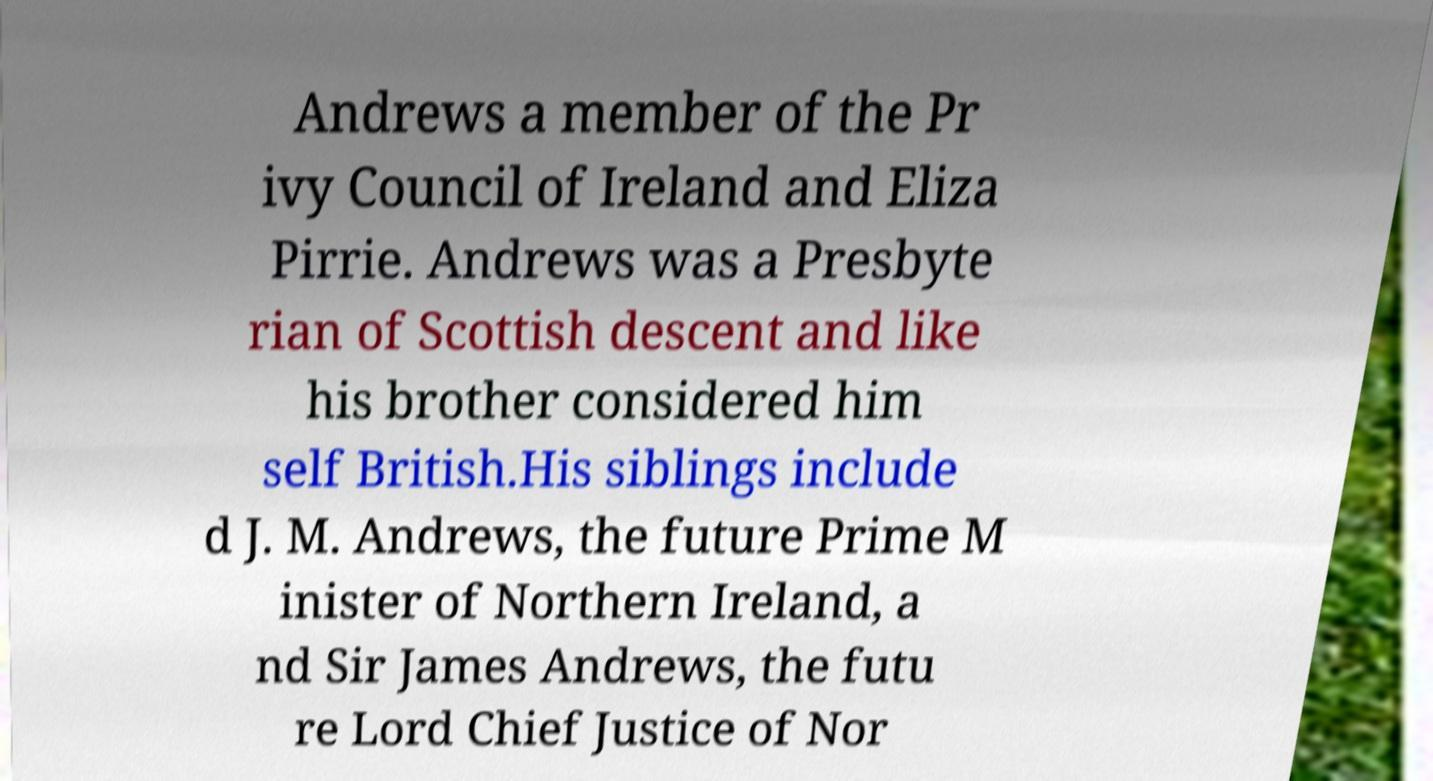I need the written content from this picture converted into text. Can you do that? Andrews a member of the Pr ivy Council of Ireland and Eliza Pirrie. Andrews was a Presbyte rian of Scottish descent and like his brother considered him self British.His siblings include d J. M. Andrews, the future Prime M inister of Northern Ireland, a nd Sir James Andrews, the futu re Lord Chief Justice of Nor 